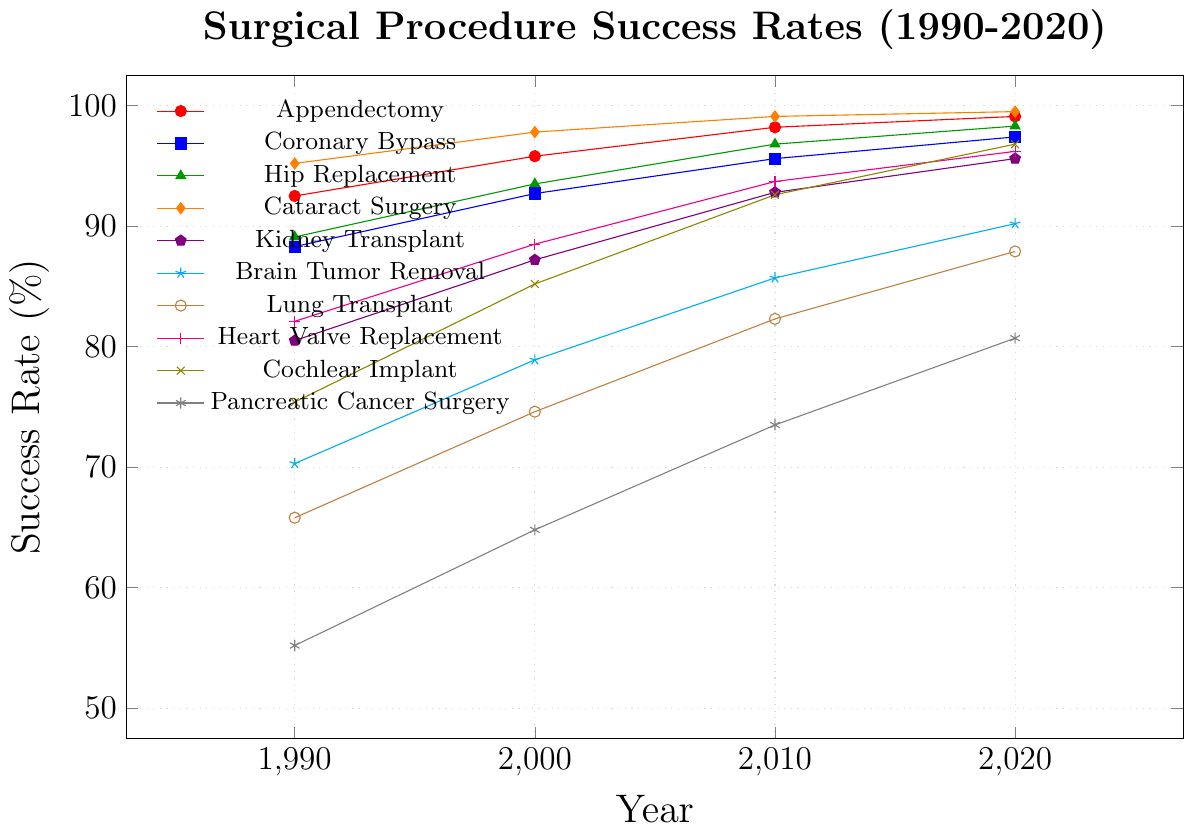What is the success rate for Cataract Surgery in 1990? By looking at the chart, locate the point labeled 'Cataract Surgery' at the year 1990 on the x-axis and read its corresponding value on the y-axis.
Answer: 95.2% How much did the success rate for Brain Tumor Removal improve from 1990 to 2020? Find the success rates for Brain Tumor Removal in 1990 and 2020. Subtract the success rate of 1990 (70.3%) from the success rate of 2020 (90.2%) to get the improvement.
Answer: 19.9% Which surgical procedure had the highest success rate in 2020? Look at the y-values for the year 2020 and identify which procedure has the highest point among all.
Answer: Cataract Surgery Between Hip Replacement and Coronary Bypass, which had a higher success rate in 2000? Locate the points for Hip Replacement and Coronary Bypass in the year 2000 and compare their y-values.
Answer: Hip Replacement What is the average success rate of Pancreatic Cancer Surgery over the years provided? Sum the success rates of Pancreatic Cancer Surgery for the years 1990, 2000, 2010, and 2020, then divide by 4: (55.2 + 64.8 + 73.5 + 80.7) / 4.
Answer: 68.55% Which procedure had the largest increase in success rate from 1990 to 2020? Calculate the increase for each procedure by subtracting the 1990 success rate from the 2020 success rate and compare these values to find the largest.
Answer: Pancreatic Cancer Surgery Did the success rate of Lung Transplant ever surpass Kidney Transplant in the years shown? Compare the y-values for Lung Transplant and Kidney Transplant for each year provided and see if Lung Transplant is ever higher.
Answer: No What is the difference in success rate between Appendectomy and Heart Valve Replacement in 2010? Find the success rates of Appendectomy and Heart Valve Replacement in 2010 and subtract the latter from the former: 98.2% - 93.7%.
Answer: 4.5% Are there any procedures that had a consistent increase in success rate in every decade shown? Inspect the trend lines of each procedure from 1990 to 2020 to check for consistent increases.
Answer: Yes Which is more common based on the success rates shown: Cochlear Implant in 2010 or Kidney Transplant in 2020? Compare the y-values of Cochlear Implant in 2010 (92.6%) and Kidney Transplant in 2020 (95.6%).
Answer: Kidney Transplant in 2020 